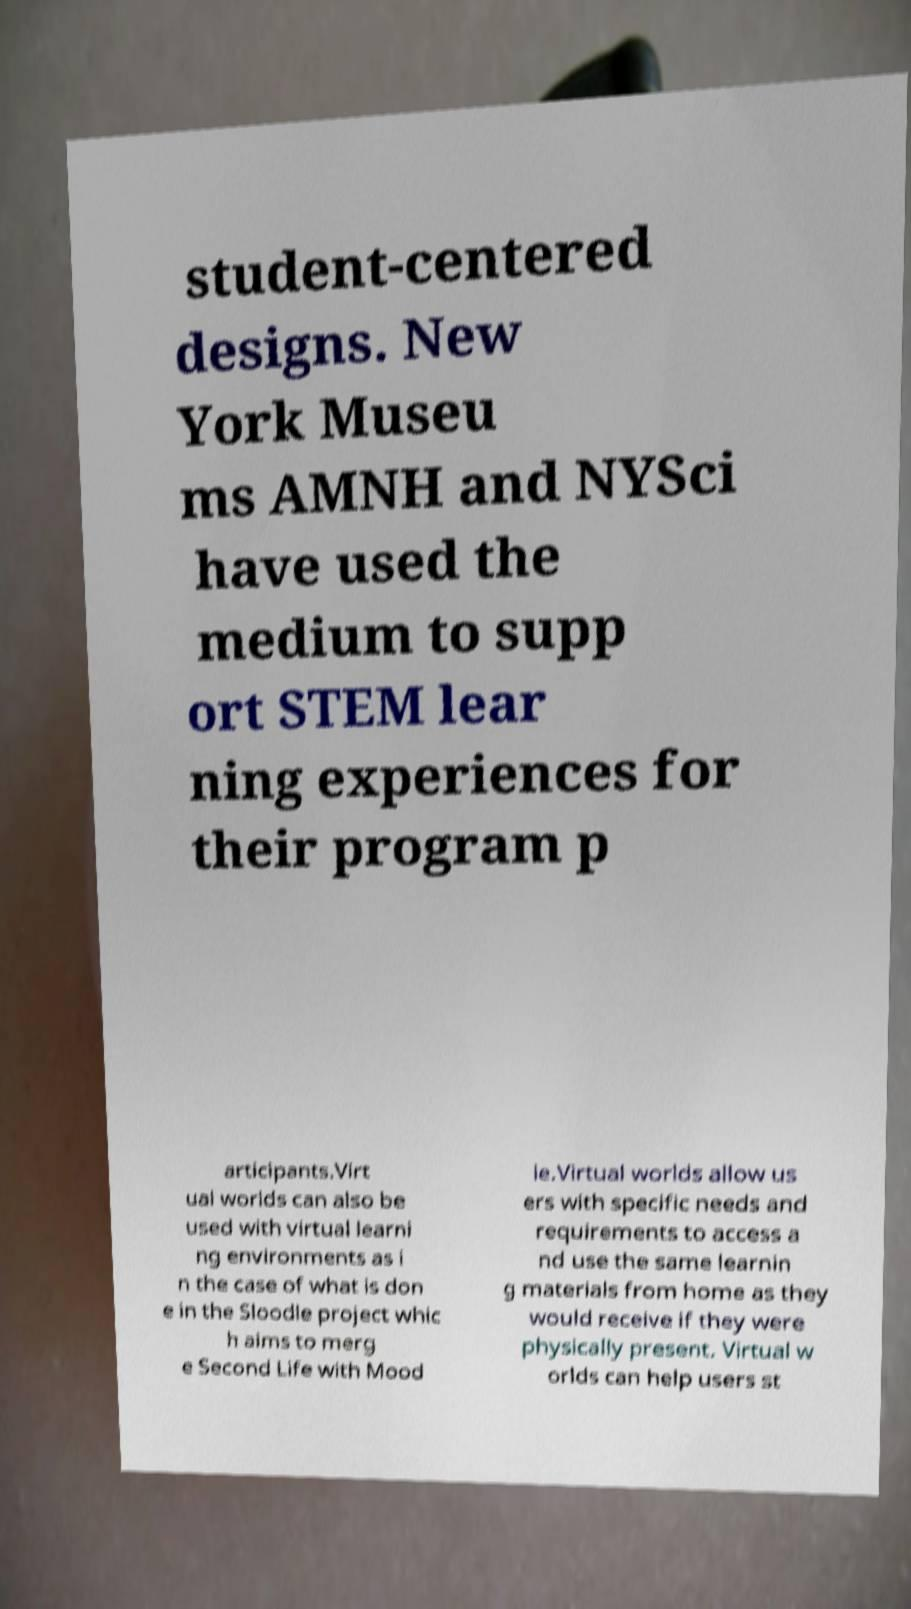There's text embedded in this image that I need extracted. Can you transcribe it verbatim? student-centered designs. New York Museu ms AMNH and NYSci have used the medium to supp ort STEM lear ning experiences for their program p articipants.Virt ual worlds can also be used with virtual learni ng environments as i n the case of what is don e in the Sloodle project whic h aims to merg e Second Life with Mood le.Virtual worlds allow us ers with specific needs and requirements to access a nd use the same learnin g materials from home as they would receive if they were physically present. Virtual w orlds can help users st 